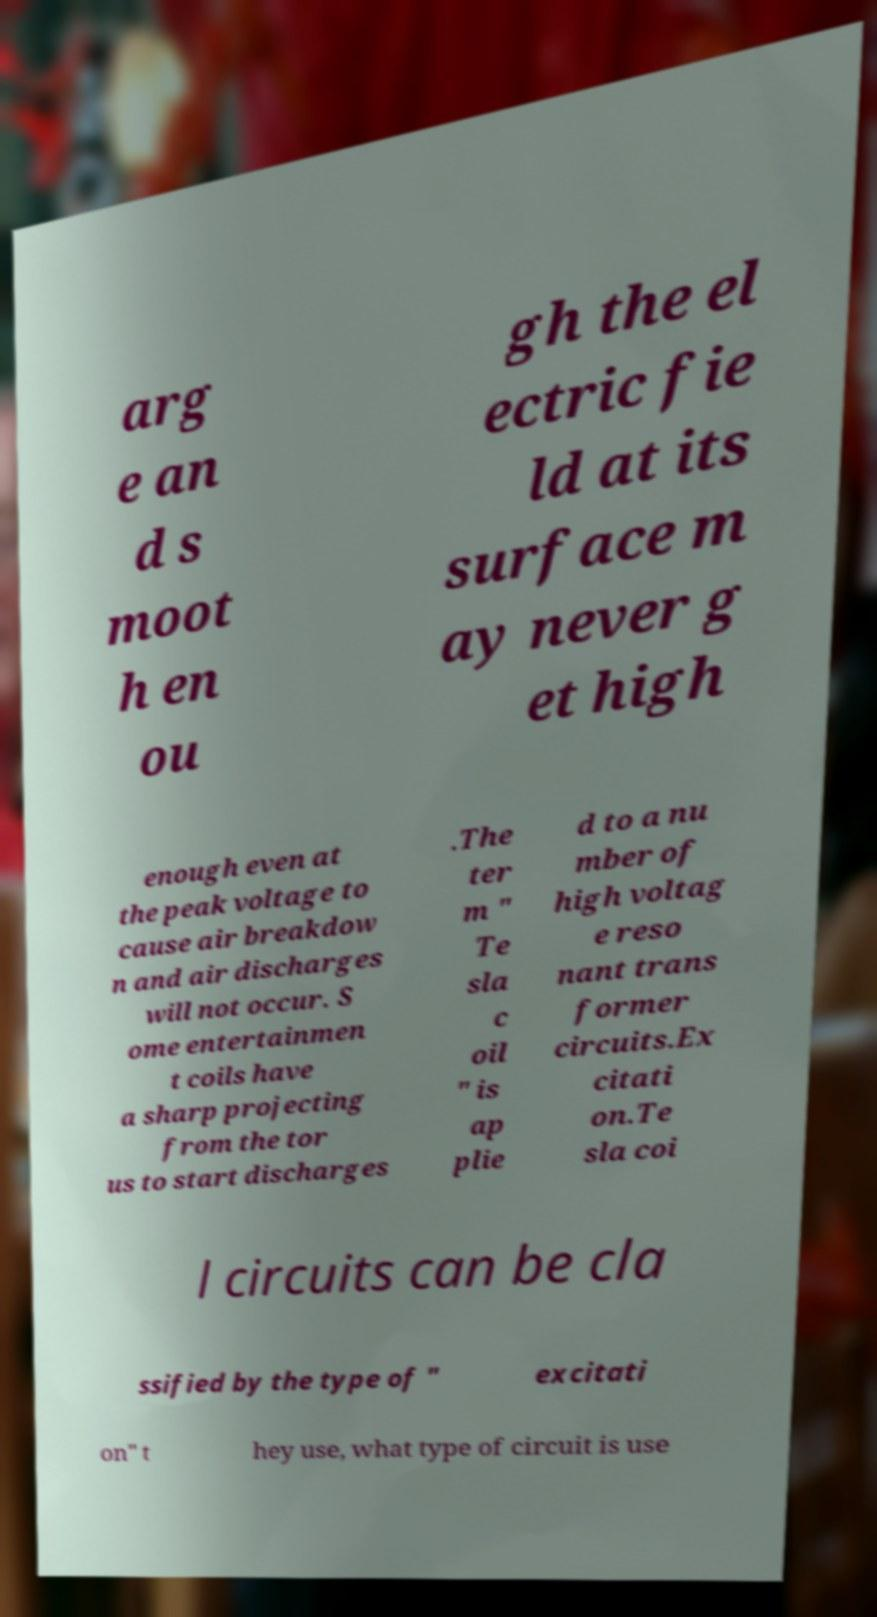Could you extract and type out the text from this image? arg e an d s moot h en ou gh the el ectric fie ld at its surface m ay never g et high enough even at the peak voltage to cause air breakdow n and air discharges will not occur. S ome entertainmen t coils have a sharp projecting from the tor us to start discharges .The ter m " Te sla c oil " is ap plie d to a nu mber of high voltag e reso nant trans former circuits.Ex citati on.Te sla coi l circuits can be cla ssified by the type of " excitati on" t hey use, what type of circuit is use 